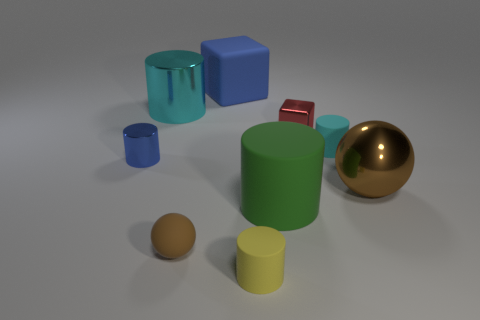What material is the small cyan object that is the same shape as the tiny blue thing?
Ensure brevity in your answer.  Rubber. Are there any tiny matte cylinders on the right side of the cube on the right side of the matte cylinder that is in front of the brown rubber sphere?
Your response must be concise. Yes. Do the blue shiny thing and the large metallic thing left of the large metallic sphere have the same shape?
Give a very brief answer. Yes. Are there any other things that have the same color as the small ball?
Provide a short and direct response. Yes. There is a small shiny object that is to the left of the red shiny block; is its color the same as the cylinder that is right of the big green cylinder?
Ensure brevity in your answer.  No. Are there any tiny brown rubber objects?
Provide a short and direct response. Yes. Are there any other tiny red cubes that have the same material as the tiny cube?
Give a very brief answer. No. Are there any other things that have the same material as the tiny sphere?
Give a very brief answer. Yes. The small block is what color?
Your answer should be very brief. Red. What shape is the shiny object that is the same color as the matte cube?
Make the answer very short. Cylinder. 